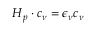Convert formula to latex. <formula><loc_0><loc_0><loc_500><loc_500>H _ { p } \cdot c _ { \nu } = \epsilon _ { \nu } c _ { \nu }</formula> 